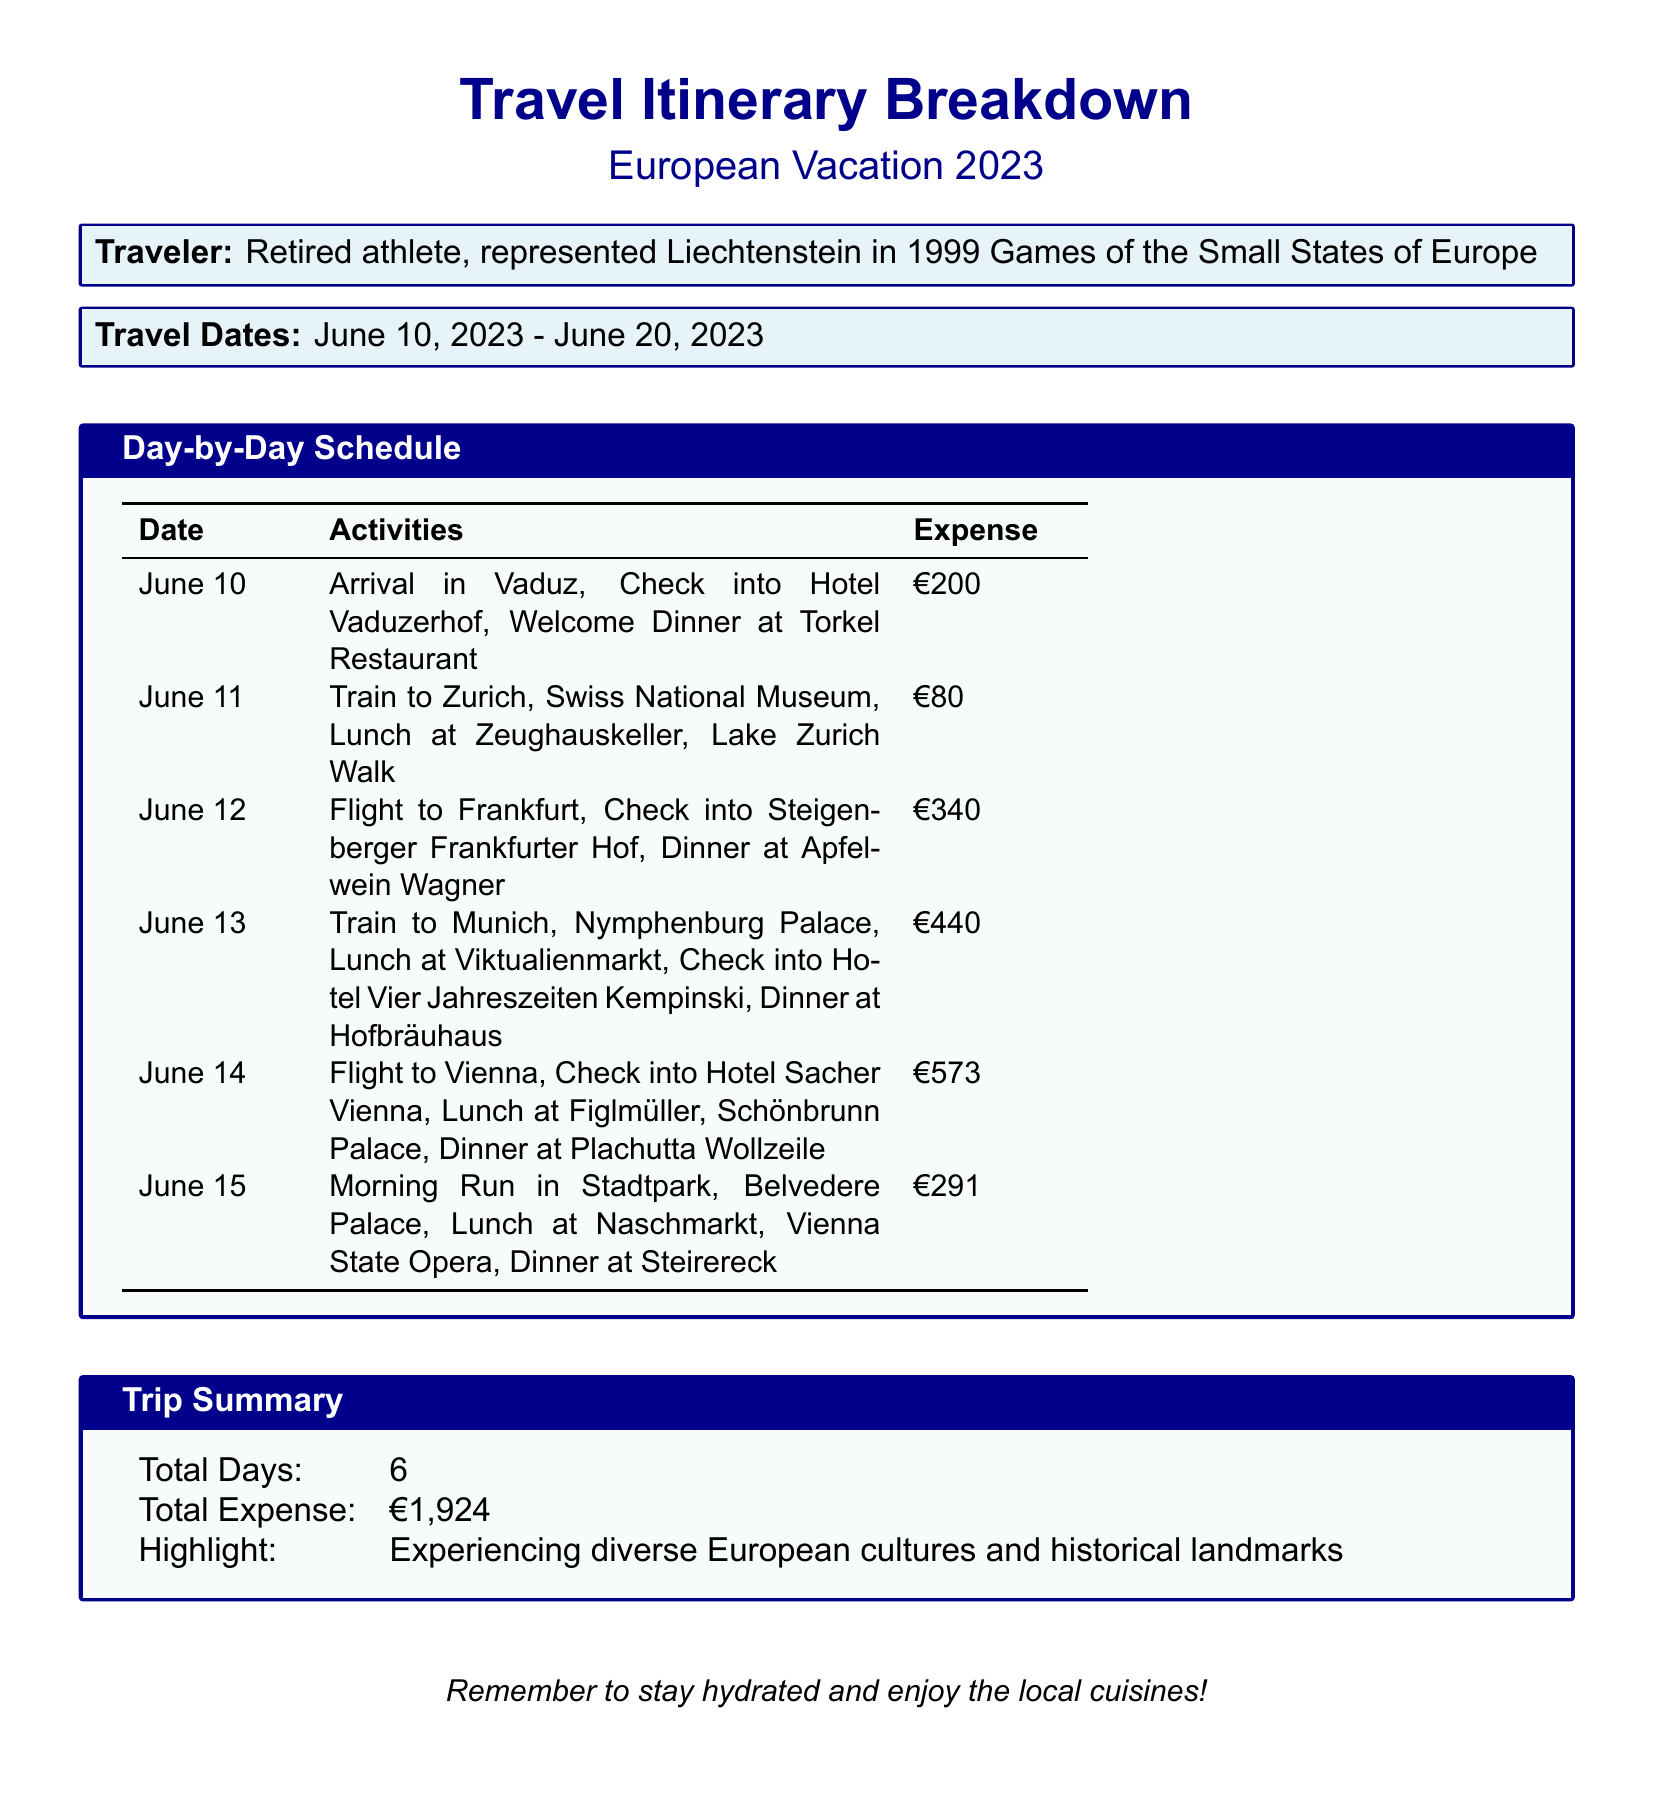What is the traveler's identity? The document states the traveler was a retired athlete representing Liechtenstein.
Answer: Retired athlete, represented Liechtenstein in 1999 Games of the Small States of Europe What are the travel dates? The document lists the travel dates from start to end.
Answer: June 10, 2023 - June 20, 2023 How many total days does the trip last? The trip summary indicates the total number of days in the trip itinerary.
Answer: 6 What was the total expense for the trip? The trip summary provides the overall cost of the vacation.
Answer: €1,924 What was the highlight of the trip? The document mentions a notable experience during the trip in the trip summary section.
Answer: Experiencing diverse European cultures and historical landmarks What activity is scheduled for June 14? The itinerary outlines the specific activity on that date.
Answer: Flight to Vienna, Check into Hotel Sacher Vienna, Lunch at Figlmüller, Schönbrunn Palace, Dinner at Plachutta Wollzeile Which restaurant was visited on June 11? The daily schedule specifies the lunch location for that date.
Answer: Lunch at Zeughauskeller What city was visited after Frankfurt? The schedule indicates the next destination following the Frankfurt flight.
Answer: Munich What type of document is this? The content and format suggest the specific type of document being utilized.
Answer: Scorecard 